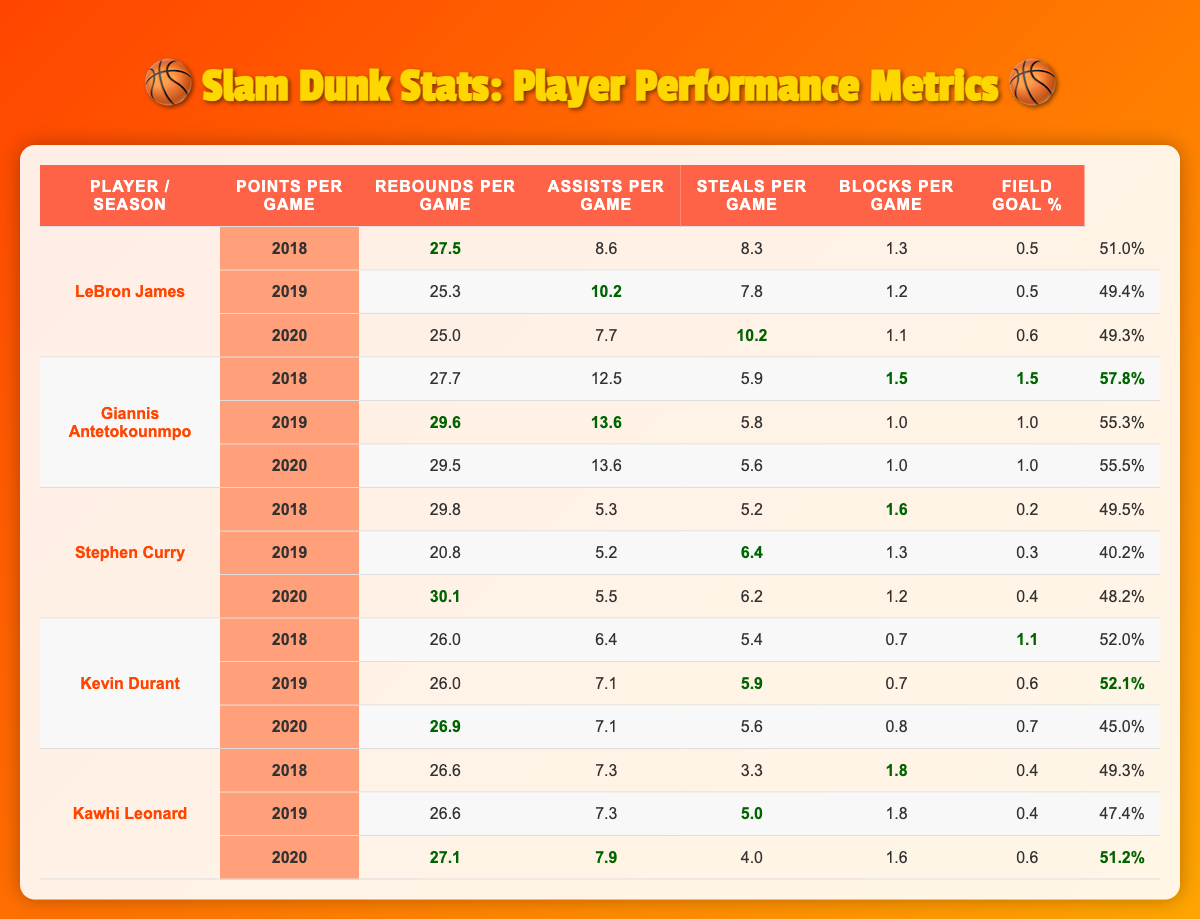What year did LeBron James have the highest points per game? In the table, the points per game for LeBron James across three seasons are 27.5 in 2018, 25.3 in 2019, and 25.0 in 2020. The highest value is 27.5 in 2018.
Answer: 2018 Which player had the lowest field goal percentage in 2019? Looking at the field goal percentages for 2019, Stephen Curry had the lowest at 40.2%, compared to 49.4% for LeBron, 55.3% for Giannis, 52.1% for Durant, and 47.4% for Kawhi.
Answer: Stephen Curry What is the total average points per game for Giannis Antetokounmpo over three seasons? For Giannis, the points per game across the three seasons are 27.7 in 2018, 29.6 in 2019, and 29.5 in 2020. Adding them gives 27.7 + 29.6 + 29.5 = 86.8. Dividing by 3, the average is approximately 28.93.
Answer: 28.93 Did Kevin Durant average more rebounds per game in 2019 than in 2018? In 2018, Durant averaged 6.4 rebounds per game, while in 2019, he averaged 7.1. Thus, he had more rebounds in 2019 than in 2018.
Answer: Yes Which player's assists peaked in the year 2020? The assists per game data shows that LeBron had 10.2 assists in 2020, which is higher than the assists recorded in previous seasons for all players.
Answer: LeBron James What is the median points per game of Kawhi Leonard from 2018 to 2020? The points per game for Kawhi from 2018, 2019, and 2020 are 26.6, 26.6, and 27.1 respectively. Arranging these numbers gives 26.6, 26.6, 27.1. The median is the middle value, which is 26.6.
Answer: 26.6 Who had the highest average steals per game over three seasons? The steals per game values for each player are compared: LeBron (1.2), Giannis (1.5), Curry (1.6), Durant (0.8), and Kawhi (1.8). Kawhi led with an average of (1.8 + 1.8 + 1.6)/3 = 1.47, making him the top player.
Answer: Kawhi Leonard Which player showed the biggest improvement in points per game from 2019 to 2020? Analyzing the points per game from 2019 to 2020, Stephen Curry's points increased from 20.8 to 30.1, a difference of 9.3. Thus, he demonstrated the largest improvement.
Answer: Stephen Curry Was Giannis more effective in steals or blocks on average over his three seasons? The steals per game averages for Giannis are 1.5, 1.0, and 1.0, giving an average of 1.17. The blocks per game are 1.5, 1.0, and 1.0, averaging to 1.17. Therefore, he was equally effective in both categories.
Answer: Equal effectiveness How many players had a field goal percentage above 50% in 2018? Reviewing each player's field goal percentage for 2018, LeBron (51.0%), Giannis (57.8%), Durant (52.0%), and Kawhi (49.3%), only LeBron, Giannis, and Durant surpassed 50%. Thus, three players did.
Answer: 3 